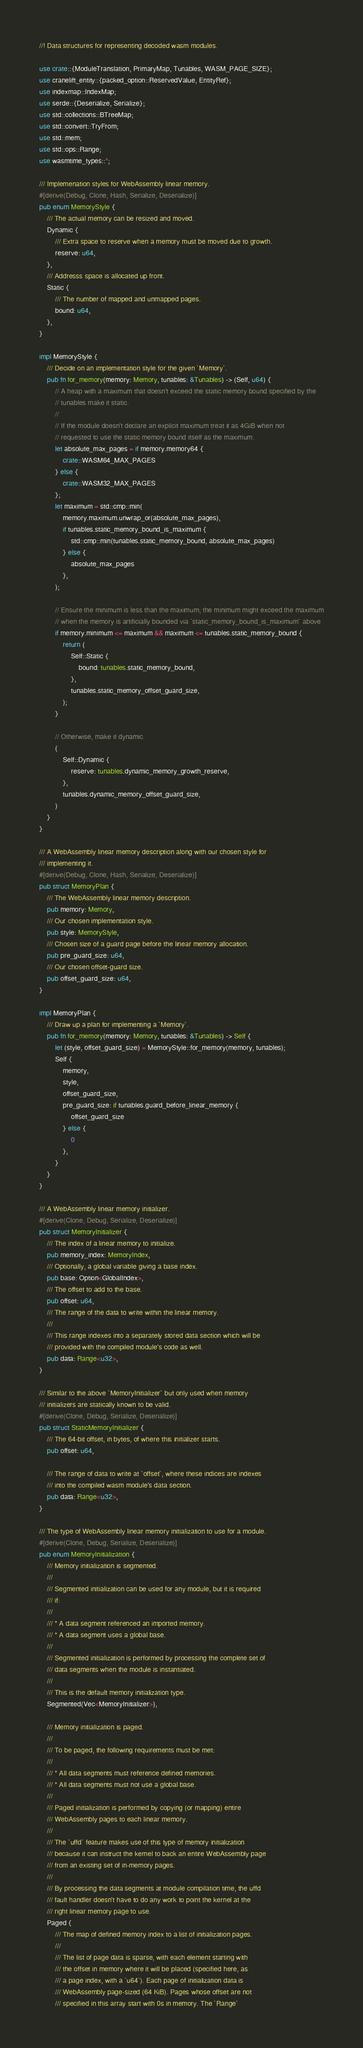<code> <loc_0><loc_0><loc_500><loc_500><_Rust_>//! Data structures for representing decoded wasm modules.

use crate::{ModuleTranslation, PrimaryMap, Tunables, WASM_PAGE_SIZE};
use cranelift_entity::{packed_option::ReservedValue, EntityRef};
use indexmap::IndexMap;
use serde::{Deserialize, Serialize};
use std::collections::BTreeMap;
use std::convert::TryFrom;
use std::mem;
use std::ops::Range;
use wasmtime_types::*;

/// Implemenation styles for WebAssembly linear memory.
#[derive(Debug, Clone, Hash, Serialize, Deserialize)]
pub enum MemoryStyle {
    /// The actual memory can be resized and moved.
    Dynamic {
        /// Extra space to reserve when a memory must be moved due to growth.
        reserve: u64,
    },
    /// Addresss space is allocated up front.
    Static {
        /// The number of mapped and unmapped pages.
        bound: u64,
    },
}

impl MemoryStyle {
    /// Decide on an implementation style for the given `Memory`.
    pub fn for_memory(memory: Memory, tunables: &Tunables) -> (Self, u64) {
        // A heap with a maximum that doesn't exceed the static memory bound specified by the
        // tunables make it static.
        //
        // If the module doesn't declare an explicit maximum treat it as 4GiB when not
        // requested to use the static memory bound itself as the maximum.
        let absolute_max_pages = if memory.memory64 {
            crate::WASM64_MAX_PAGES
        } else {
            crate::WASM32_MAX_PAGES
        };
        let maximum = std::cmp::min(
            memory.maximum.unwrap_or(absolute_max_pages),
            if tunables.static_memory_bound_is_maximum {
                std::cmp::min(tunables.static_memory_bound, absolute_max_pages)
            } else {
                absolute_max_pages
            },
        );

        // Ensure the minimum is less than the maximum; the minimum might exceed the maximum
        // when the memory is artificially bounded via `static_memory_bound_is_maximum` above
        if memory.minimum <= maximum && maximum <= tunables.static_memory_bound {
            return (
                Self::Static {
                    bound: tunables.static_memory_bound,
                },
                tunables.static_memory_offset_guard_size,
            );
        }

        // Otherwise, make it dynamic.
        (
            Self::Dynamic {
                reserve: tunables.dynamic_memory_growth_reserve,
            },
            tunables.dynamic_memory_offset_guard_size,
        )
    }
}

/// A WebAssembly linear memory description along with our chosen style for
/// implementing it.
#[derive(Debug, Clone, Hash, Serialize, Deserialize)]
pub struct MemoryPlan {
    /// The WebAssembly linear memory description.
    pub memory: Memory,
    /// Our chosen implementation style.
    pub style: MemoryStyle,
    /// Chosen size of a guard page before the linear memory allocation.
    pub pre_guard_size: u64,
    /// Our chosen offset-guard size.
    pub offset_guard_size: u64,
}

impl MemoryPlan {
    /// Draw up a plan for implementing a `Memory`.
    pub fn for_memory(memory: Memory, tunables: &Tunables) -> Self {
        let (style, offset_guard_size) = MemoryStyle::for_memory(memory, tunables);
        Self {
            memory,
            style,
            offset_guard_size,
            pre_guard_size: if tunables.guard_before_linear_memory {
                offset_guard_size
            } else {
                0
            },
        }
    }
}

/// A WebAssembly linear memory initializer.
#[derive(Clone, Debug, Serialize, Deserialize)]
pub struct MemoryInitializer {
    /// The index of a linear memory to initialize.
    pub memory_index: MemoryIndex,
    /// Optionally, a global variable giving a base index.
    pub base: Option<GlobalIndex>,
    /// The offset to add to the base.
    pub offset: u64,
    /// The range of the data to write within the linear memory.
    ///
    /// This range indexes into a separately stored data section which will be
    /// provided with the compiled module's code as well.
    pub data: Range<u32>,
}

/// Similar to the above `MemoryInitializer` but only used when memory
/// initializers are statically known to be valid.
#[derive(Clone, Debug, Serialize, Deserialize)]
pub struct StaticMemoryInitializer {
    /// The 64-bit offset, in bytes, of where this initializer starts.
    pub offset: u64,

    /// The range of data to write at `offset`, where these indices are indexes
    /// into the compiled wasm module's data section.
    pub data: Range<u32>,
}

/// The type of WebAssembly linear memory initialization to use for a module.
#[derive(Clone, Debug, Serialize, Deserialize)]
pub enum MemoryInitialization {
    /// Memory initialization is segmented.
    ///
    /// Segmented initialization can be used for any module, but it is required
    /// if:
    ///
    /// * A data segment referenced an imported memory.
    /// * A data segment uses a global base.
    ///
    /// Segmented initialization is performed by processing the complete set of
    /// data segments when the module is instantiated.
    ///
    /// This is the default memory initialization type.
    Segmented(Vec<MemoryInitializer>),

    /// Memory initialization is paged.
    ///
    /// To be paged, the following requirements must be met:
    ///
    /// * All data segments must reference defined memories.
    /// * All data segments must not use a global base.
    ///
    /// Paged initialization is performed by copying (or mapping) entire
    /// WebAssembly pages to each linear memory.
    ///
    /// The `uffd` feature makes use of this type of memory initialization
    /// because it can instruct the kernel to back an entire WebAssembly page
    /// from an existing set of in-memory pages.
    ///
    /// By processing the data segments at module compilation time, the uffd
    /// fault handler doesn't have to do any work to point the kernel at the
    /// right linear memory page to use.
    Paged {
        /// The map of defined memory index to a list of initialization pages.
        ///
        /// The list of page data is sparse, with each element starting with
        /// the offset in memory where it will be placed (specified here, as
        /// a page index, with a `u64`). Each page of initialization data is
        /// WebAssembly page-sized (64 KiB). Pages whose offset are not
        /// specified in this array start with 0s in memory. The `Range`</code> 